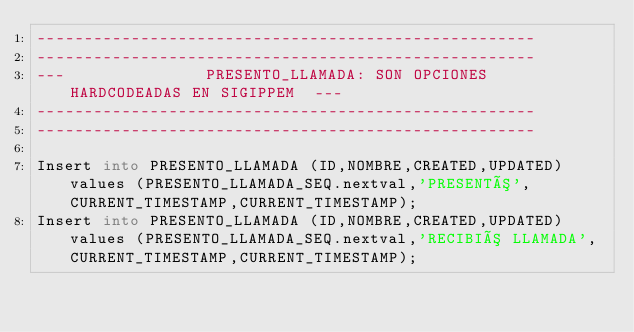<code> <loc_0><loc_0><loc_500><loc_500><_SQL_>-----------------------------------------------------
-----------------------------------------------------
---               PRESENTO_LLAMADA: SON OPCIONES HARDCODEADAS EN SIGIPPEM  ---
-----------------------------------------------------
-----------------------------------------------------

Insert into PRESENTO_LLAMADA (ID,NOMBRE,CREATED,UPDATED) values (PRESENTO_LLAMADA_SEQ.nextval,'PRESENTÓ',CURRENT_TIMESTAMP,CURRENT_TIMESTAMP);
Insert into PRESENTO_LLAMADA (ID,NOMBRE,CREATED,UPDATED) values (PRESENTO_LLAMADA_SEQ.nextval,'RECIBIÓ LLAMADA',CURRENT_TIMESTAMP,CURRENT_TIMESTAMP);
</code> 